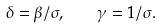<formula> <loc_0><loc_0><loc_500><loc_500>\delta = \beta / { \sigma } , \quad \gamma = { 1 } / { \sigma } .</formula> 